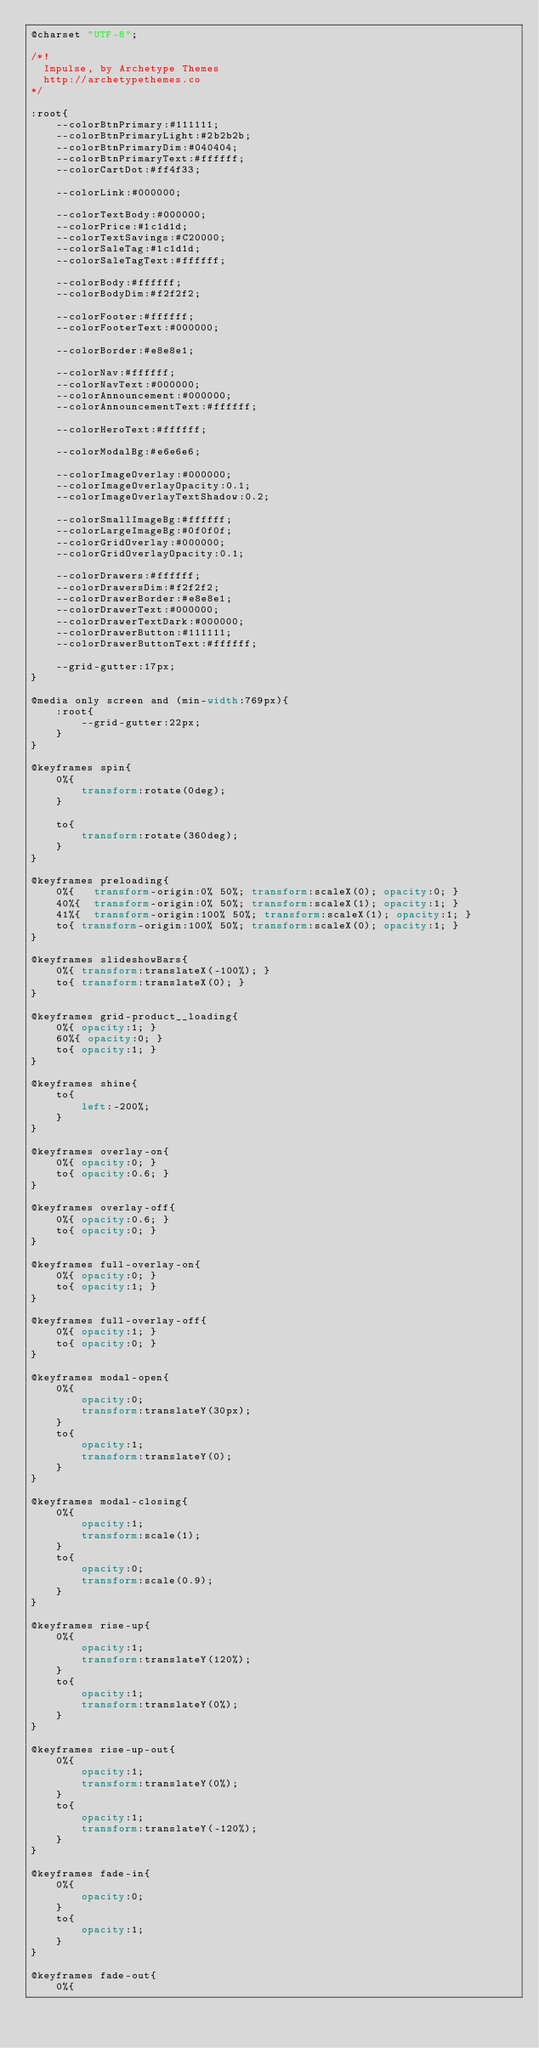<code> <loc_0><loc_0><loc_500><loc_500><_CSS_>@charset "UTF-8";

/*!
  Impulse, by Archetype Themes
  http://archetypethemes.co
*/

:root{
    --colorBtnPrimary:#111111;
    --colorBtnPrimaryLight:#2b2b2b;
    --colorBtnPrimaryDim:#040404;
    --colorBtnPrimaryText:#ffffff;
    --colorCartDot:#ff4f33;

    --colorLink:#000000;

    --colorTextBody:#000000;
    --colorPrice:#1c1d1d;
    --colorTextSavings:#C20000;
    --colorSaleTag:#1c1d1d;
    --colorSaleTagText:#ffffff;

    --colorBody:#ffffff;
    --colorBodyDim:#f2f2f2;

    --colorFooter:#ffffff;
    --colorFooterText:#000000;

    --colorBorder:#e8e8e1;

    --colorNav:#ffffff;
    --colorNavText:#000000;
    --colorAnnouncement:#000000;
    --colorAnnouncementText:#ffffff;

    --colorHeroText:#ffffff;

    --colorModalBg:#e6e6e6;

    --colorImageOverlay:#000000;
    --colorImageOverlayOpacity:0.1;
    --colorImageOverlayTextShadow:0.2;

    --colorSmallImageBg:#ffffff;
    --colorLargeImageBg:#0f0f0f;
    --colorGridOverlay:#000000;
    --colorGridOverlayOpacity:0.1;

    --colorDrawers:#ffffff;
    --colorDrawersDim:#f2f2f2;
    --colorDrawerBorder:#e8e8e1;
    --colorDrawerText:#000000;
    --colorDrawerTextDark:#000000;
    --colorDrawerButton:#111111;
    --colorDrawerButtonText:#ffffff;

    --grid-gutter:17px;
}

@media only screen and (min-width:769px){
    :root{
        --grid-gutter:22px;
    }
}

@keyframes spin{
    0%{
        transform:rotate(0deg);
    }

    to{
        transform:rotate(360deg);
    }
}

@keyframes preloading{
    0%{   transform-origin:0% 50%; transform:scaleX(0); opacity:0; }
    40%{  transform-origin:0% 50%; transform:scaleX(1); opacity:1; }
    41%{  transform-origin:100% 50%; transform:scaleX(1); opacity:1; }
    to{ transform-origin:100% 50%; transform:scaleX(0); opacity:1; }
}

@keyframes slideshowBars{
    0%{ transform:translateX(-100%); }
    to{ transform:translateX(0); }
}

@keyframes grid-product__loading{
    0%{ opacity:1; }
    60%{ opacity:0; }
    to{ opacity:1; }
}

@keyframes shine{
    to{
        left:-200%;
    }
}

@keyframes overlay-on{
    0%{ opacity:0; }
    to{ opacity:0.6; }
}

@keyframes overlay-off{
    0%{ opacity:0.6; }
    to{ opacity:0; }
}

@keyframes full-overlay-on{
    0%{ opacity:0; }
    to{ opacity:1; }
}

@keyframes full-overlay-off{
    0%{ opacity:1; }
    to{ opacity:0; }
}

@keyframes modal-open{
    0%{
        opacity:0;
        transform:translateY(30px);
    }
    to{
        opacity:1;
        transform:translateY(0);
    }
}

@keyframes modal-closing{
    0%{
        opacity:1;
        transform:scale(1);
    }
    to{
        opacity:0;
        transform:scale(0.9);
    }
}

@keyframes rise-up{
    0%{
        opacity:1;
        transform:translateY(120%);
    }
    to{
        opacity:1;
        transform:translateY(0%);
    }
}

@keyframes rise-up-out{
    0%{
        opacity:1;
        transform:translateY(0%);
    }
    to{
        opacity:1;
        transform:translateY(-120%);
    }
}

@keyframes fade-in{
    0%{
        opacity:0;
    }
    to{
        opacity:1;
    }
}

@keyframes fade-out{
    0%{</code> 